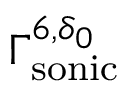<formula> <loc_0><loc_0><loc_500><loc_500>\Gamma _ { s o n i c } ^ { 6 , \delta _ { 0 } }</formula> 